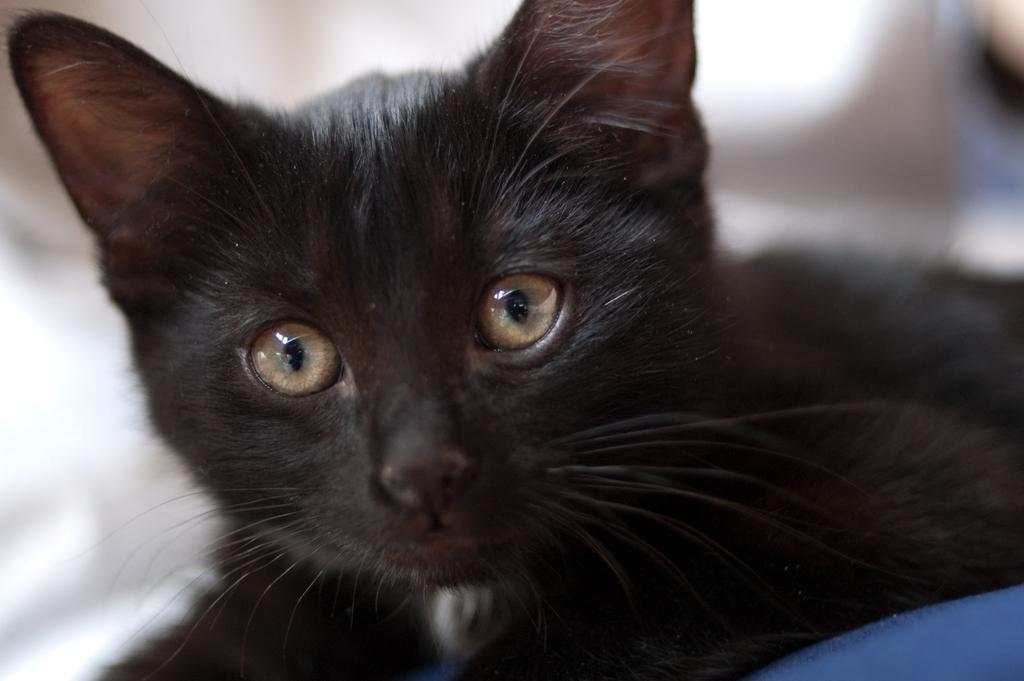Describe this image in one or two sentences. In this picture there is a black cat who is lying on the blue color chair or couch. In the background I can see the blur image. 